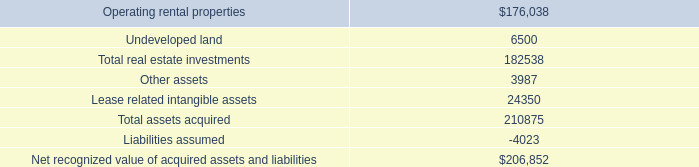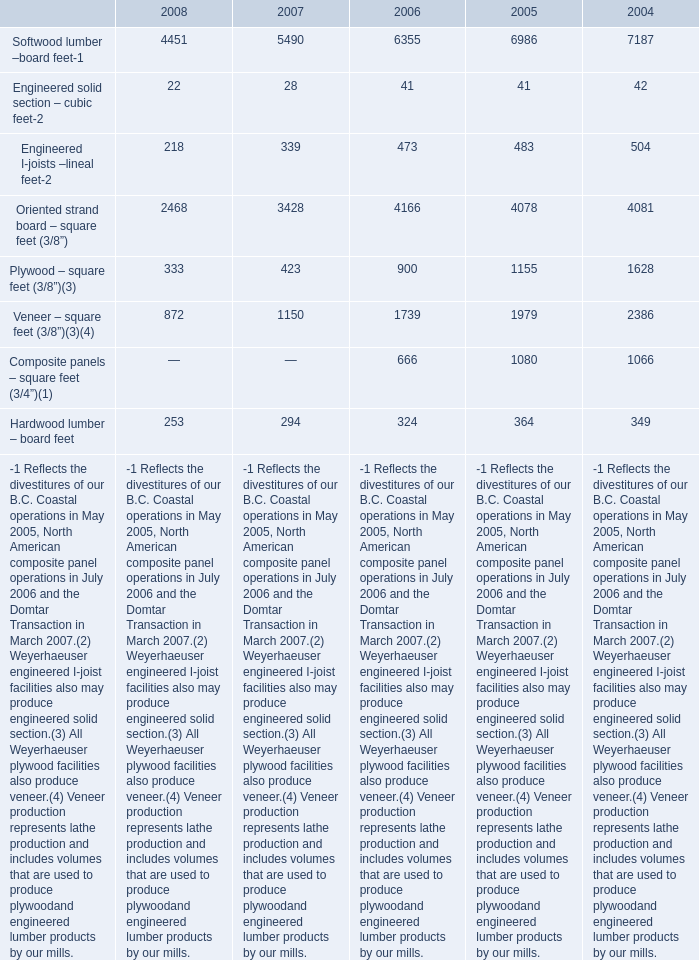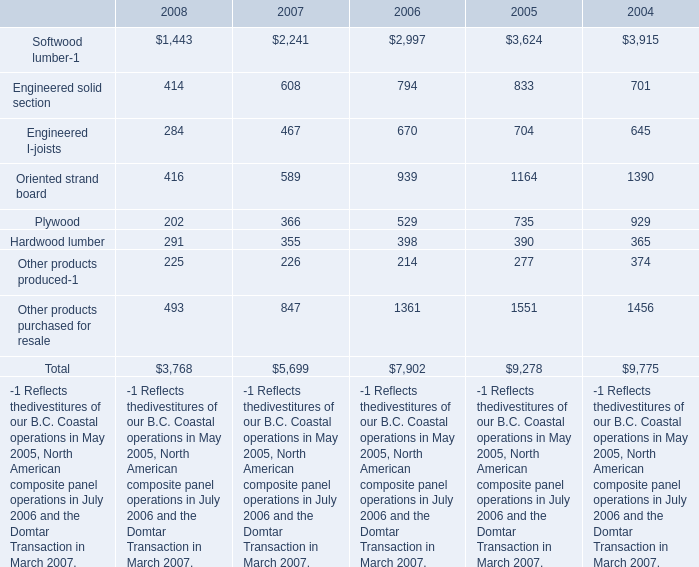Is the total amount of all elements in 2007 greater than that in 2008? 
Computations: ((((((5490 + 28) + 339) + 3428) + 423) + 1150) + 294)
Answer: 11152.0. 